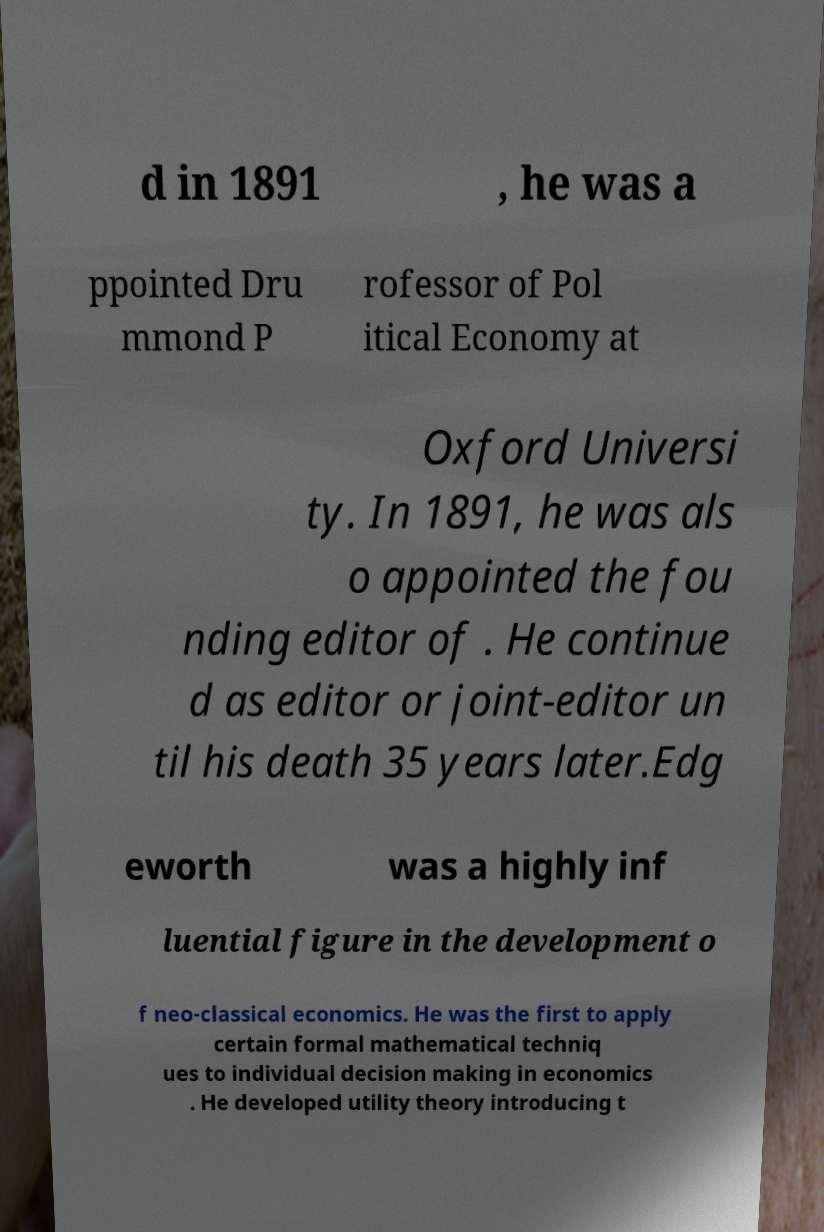Could you assist in decoding the text presented in this image and type it out clearly? d in 1891 , he was a ppointed Dru mmond P rofessor of Pol itical Economy at Oxford Universi ty. In 1891, he was als o appointed the fou nding editor of . He continue d as editor or joint-editor un til his death 35 years later.Edg eworth was a highly inf luential figure in the development o f neo-classical economics. He was the first to apply certain formal mathematical techniq ues to individual decision making in economics . He developed utility theory introducing t 